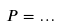Convert formula to latex. <formula><loc_0><loc_0><loc_500><loc_500>P = \dots</formula> 